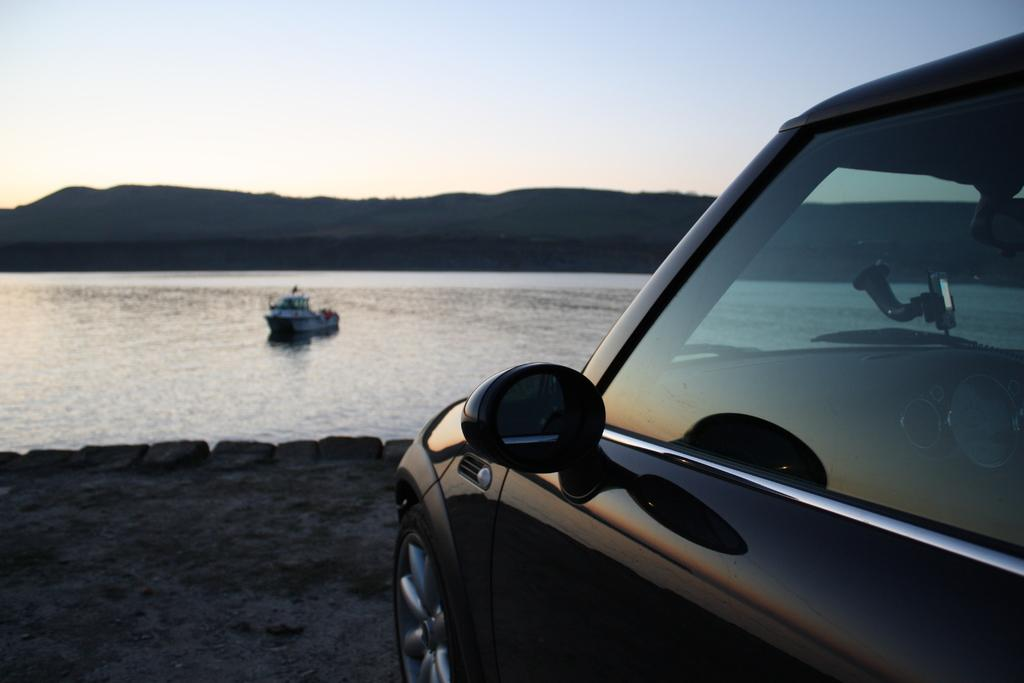What is the main subject in the front of the image? There is a vehicle in the front of the image. What can be seen in the background of the image? There is a hill, water, a boat, and the sky visible in the background of the image. Can you describe the landscape in the background? The background features a hill, water, and a boat, suggesting a scene near a body of water. What part of the natural environment is visible in the image? The sky is visible in the background of the image. What time does the clock in the image show? There is no clock present in the image. Can you describe the twig that is holding up the boat in the image? There is no twig holding up the boat in the image; the boat is floating on the water. 